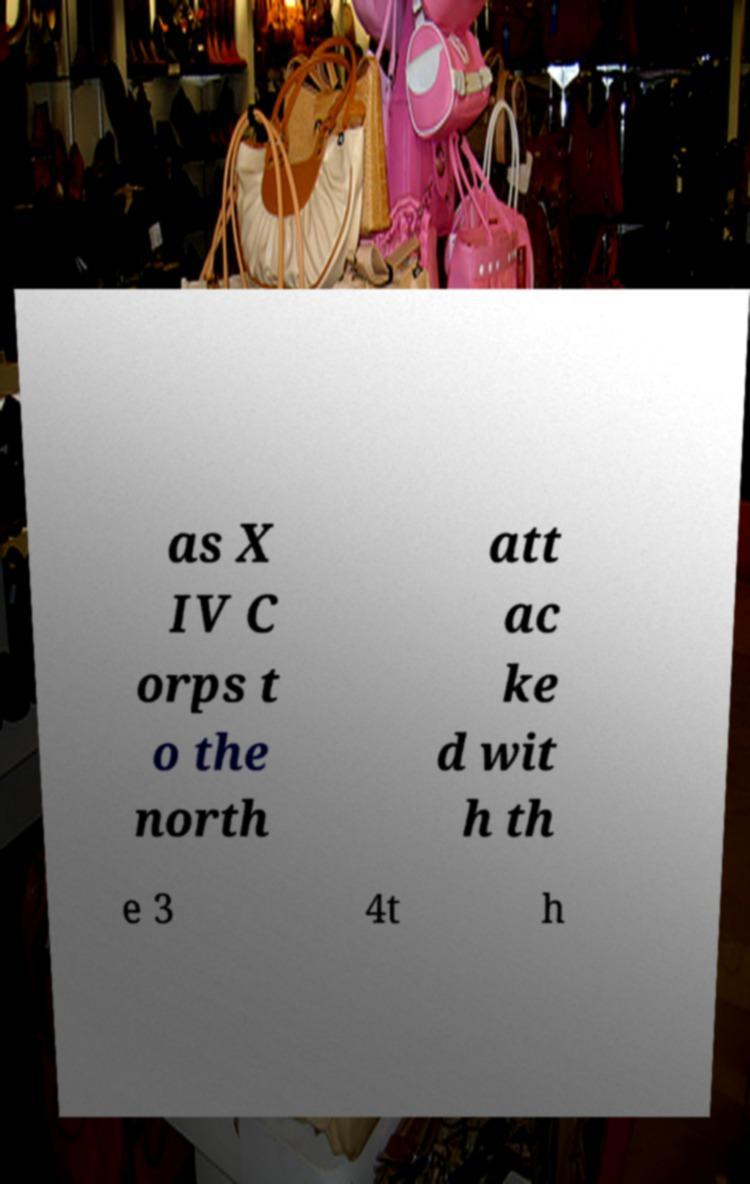What messages or text are displayed in this image? I need them in a readable, typed format. as X IV C orps t o the north att ac ke d wit h th e 3 4t h 